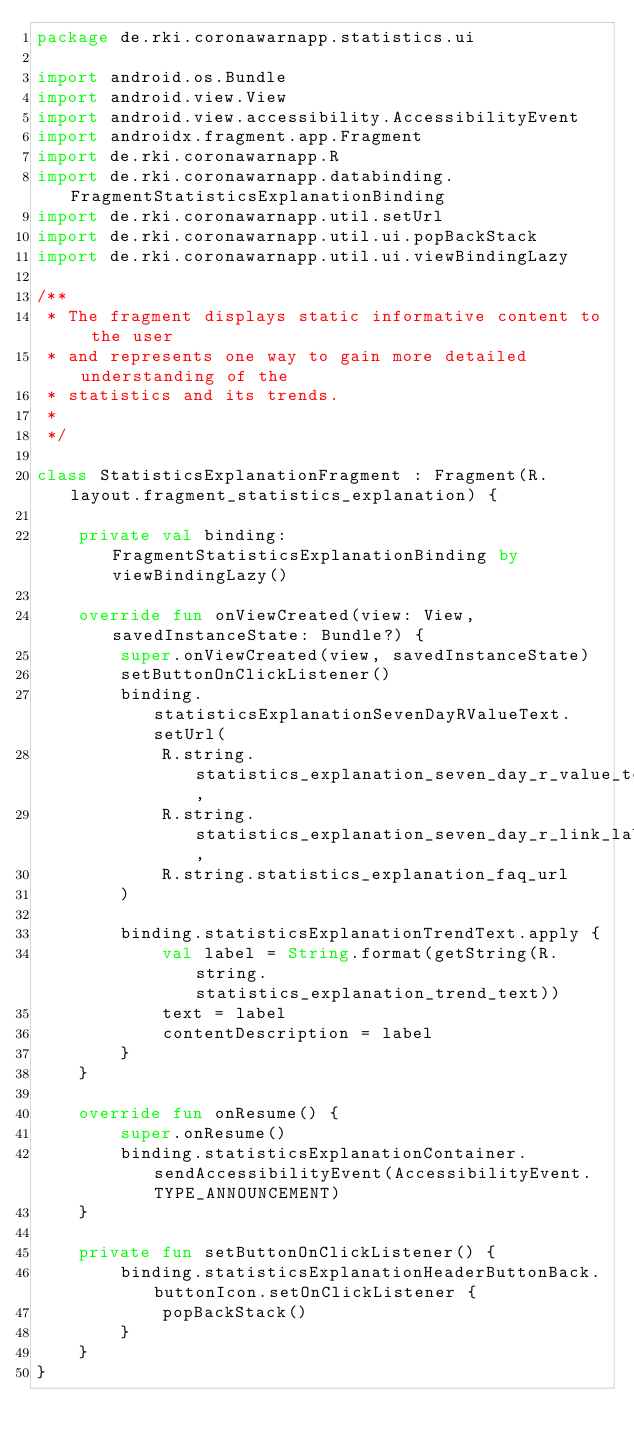<code> <loc_0><loc_0><loc_500><loc_500><_Kotlin_>package de.rki.coronawarnapp.statistics.ui

import android.os.Bundle
import android.view.View
import android.view.accessibility.AccessibilityEvent
import androidx.fragment.app.Fragment
import de.rki.coronawarnapp.R
import de.rki.coronawarnapp.databinding.FragmentStatisticsExplanationBinding
import de.rki.coronawarnapp.util.setUrl
import de.rki.coronawarnapp.util.ui.popBackStack
import de.rki.coronawarnapp.util.ui.viewBindingLazy

/**
 * The fragment displays static informative content to the user
 * and represents one way to gain more detailed understanding of the
 * statistics and its trends.
 *
 */

class StatisticsExplanationFragment : Fragment(R.layout.fragment_statistics_explanation) {

    private val binding: FragmentStatisticsExplanationBinding by viewBindingLazy()

    override fun onViewCreated(view: View, savedInstanceState: Bundle?) {
        super.onViewCreated(view, savedInstanceState)
        setButtonOnClickListener()
        binding.statisticsExplanationSevenDayRValueText.setUrl(
            R.string.statistics_explanation_seven_day_r_value_text,
            R.string.statistics_explanation_seven_day_r_link_label,
            R.string.statistics_explanation_faq_url
        )

        binding.statisticsExplanationTrendText.apply {
            val label = String.format(getString(R.string.statistics_explanation_trend_text))
            text = label
            contentDescription = label
        }
    }

    override fun onResume() {
        super.onResume()
        binding.statisticsExplanationContainer.sendAccessibilityEvent(AccessibilityEvent.TYPE_ANNOUNCEMENT)
    }

    private fun setButtonOnClickListener() {
        binding.statisticsExplanationHeaderButtonBack.buttonIcon.setOnClickListener {
            popBackStack()
        }
    }
}
</code> 